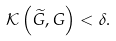Convert formula to latex. <formula><loc_0><loc_0><loc_500><loc_500>\mathcal { K } \left ( \widetilde { G } , G \right ) < \delta .</formula> 